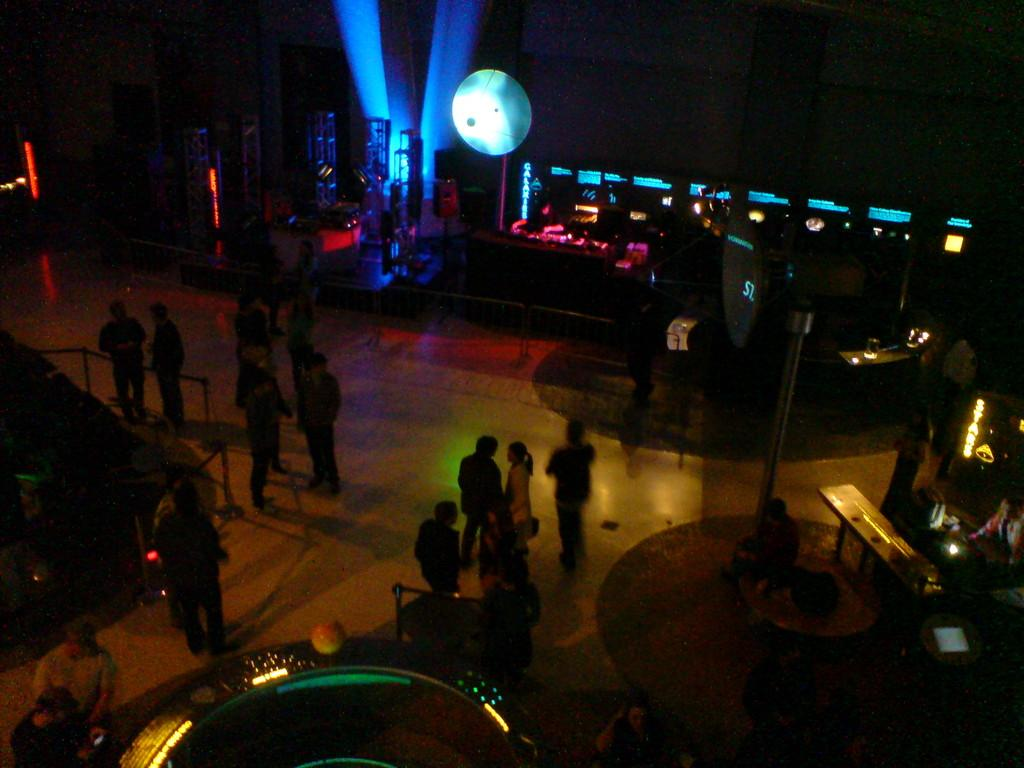What can be seen in the image involving people? There are people standing in the image. Where are the people standing? The people are standing on the floor. What object is located on the right side of the image? There is a bench on the right side of the image. What can be seen in the background of the image? Colorful lights are visible in the background of the image. What shape is the cushion on the bench in the image? There is no cushion present on the bench in the image. What type of voice can be heard coming from the people in the image? The image is a still picture, so there is no sound or voice present. 